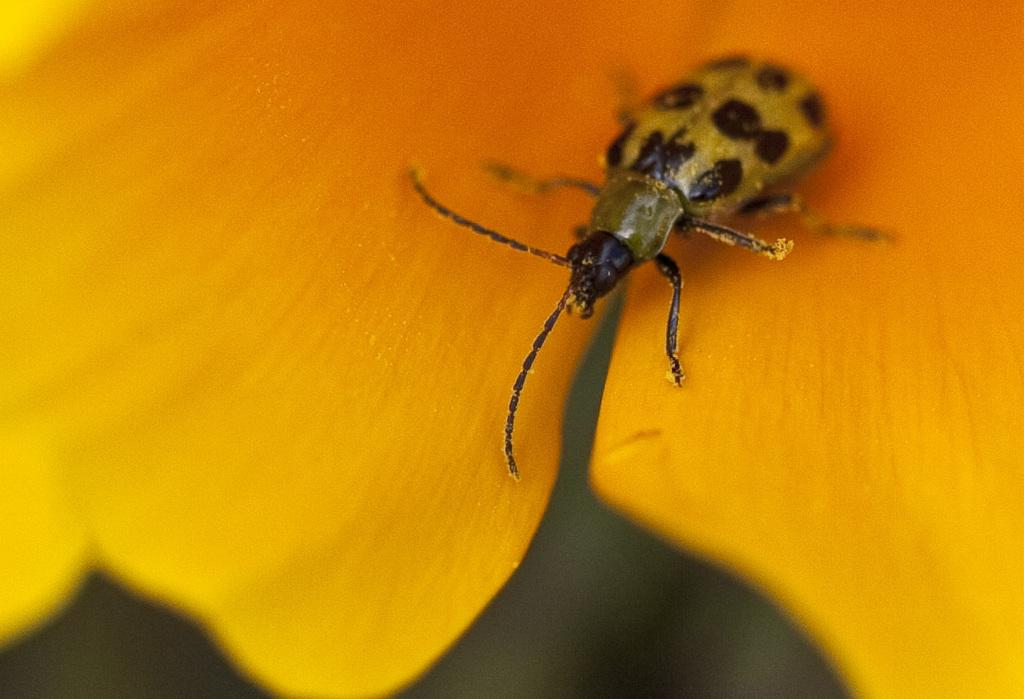What type of creature can be seen in the image? There is an insect in the image. Where is the insect located? The insect is on a flower. What type of bird can be seen in the image? There is no bird present in the image; it features an insect on a flower. What type of shoe is visible in the image? There is no shoe present in the image. 